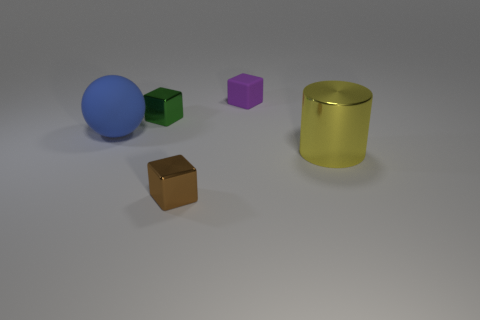Add 3 large things. How many objects exist? 8 Subtract all cylinders. How many objects are left? 4 Subtract 0 blue cylinders. How many objects are left? 5 Subtract all tiny things. Subtract all small cyan metal cubes. How many objects are left? 2 Add 1 big matte balls. How many big matte balls are left? 2 Add 1 blue matte objects. How many blue matte objects exist? 2 